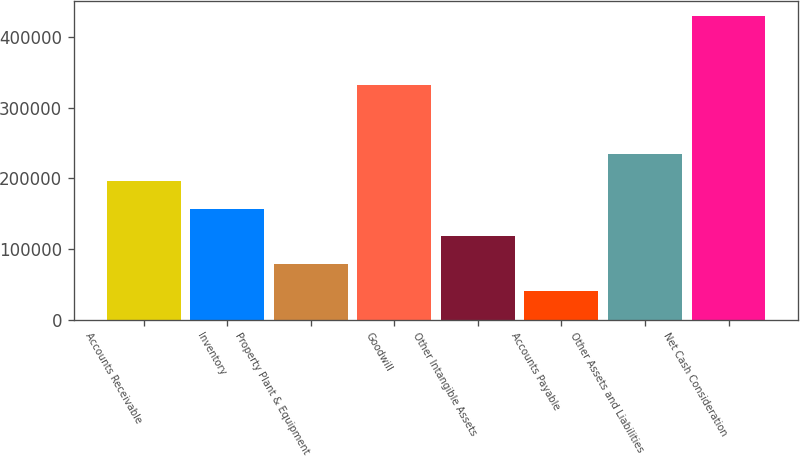<chart> <loc_0><loc_0><loc_500><loc_500><bar_chart><fcel>Accounts Receivable<fcel>Inventory<fcel>Property Plant & Equipment<fcel>Goodwill<fcel>Other Intangible Assets<fcel>Accounts Payable<fcel>Other Assets and Liabilities<fcel>Net Cash Consideration<nl><fcel>195968<fcel>157065<fcel>79260.4<fcel>331806<fcel>118163<fcel>40358<fcel>234870<fcel>429382<nl></chart> 